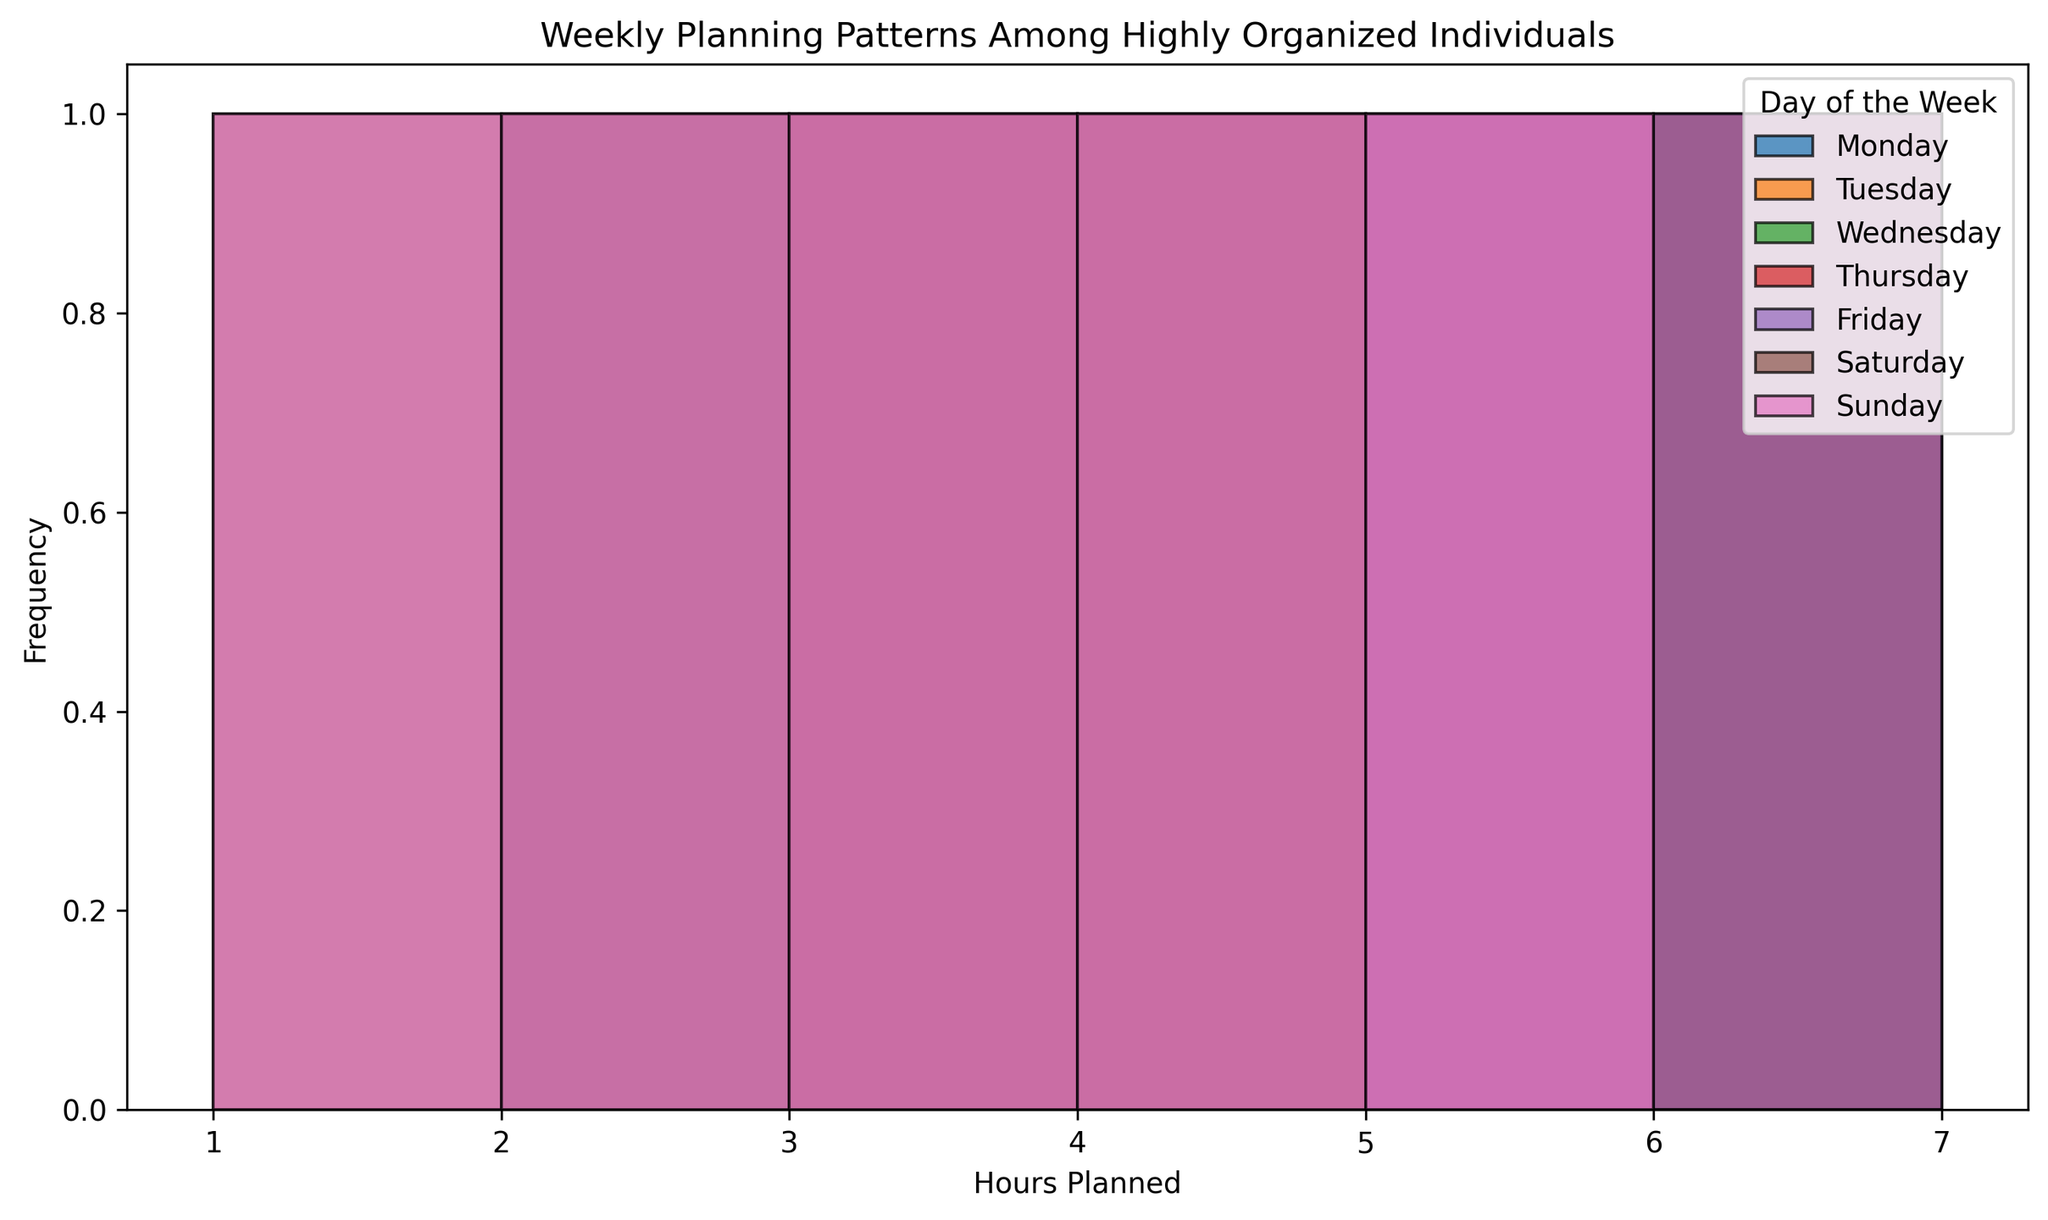What's the most frequent number of hours planned on Monday? To determine this, look at the histogram for Monday. The bar with the greatest height indicates the most frequent number of hours.
Answer: 3 Which day has the highest frequency for 5 hours of planning? Check the histograms for each day and identify which one has the tallest bar at the 5-hour mark. That would be the day with the highest frequency for 5 hours of planning.
Answer: Monday Is there any day where 1 hour of planning has the highest frequency? To find this, examine each histogram where 1 hour is represented. If the bar for 1 hour is the highest among all other bars for that day, then 1 hour has the highest frequency.
Answer: Saturday What's the total frequency of planning 4 hours across all days? Sum the heights of the bars that represent 4 hours from the histograms for each day. This includes counting how many times 4 hours of planning appears across all days.
Answer: 7 Which day has a more balanced distribution of hours planned, meaning the frequencies are similar across different hours? Compare the histograms and look for the day where the bar heights are relatively similar, demonstrating that no single hour dominates the others in frequency.
Answer: Thursday Is there any day where planning 6 hours occurs more frequently than planning 2 hours? Check the histograms for each day and compare the bars for 6 hours and 2 hours. If the bar for 6 hours is taller, that day is the answer.
Answer: Monday, Tuesday, Wednesday, Thursday, Friday Which day has the least variation in hours planned, meaning the frequencies don’t differ much? Look for the histogram where the heights of the bars are most similar and close to each other, indicating little variation.
Answer: Tuesday On what day is there the highest frequency of planning 3 hours? Find the bar for 3 hours on each histogram and identify which one has the highest frequency.
Answer: Monday How does the frequency of 1-hour planning compare between Saturday and Sunday? Look at the bars for 1 hour on Saturday and Sunday and compare their heights.
Answer: Same What’s the combined frequency for 2 hours planned on the weekends (Saturday and Sunday)? Find the bars for 2 hours on both days and sum their heights to get the combined frequency.
Answer: 4 